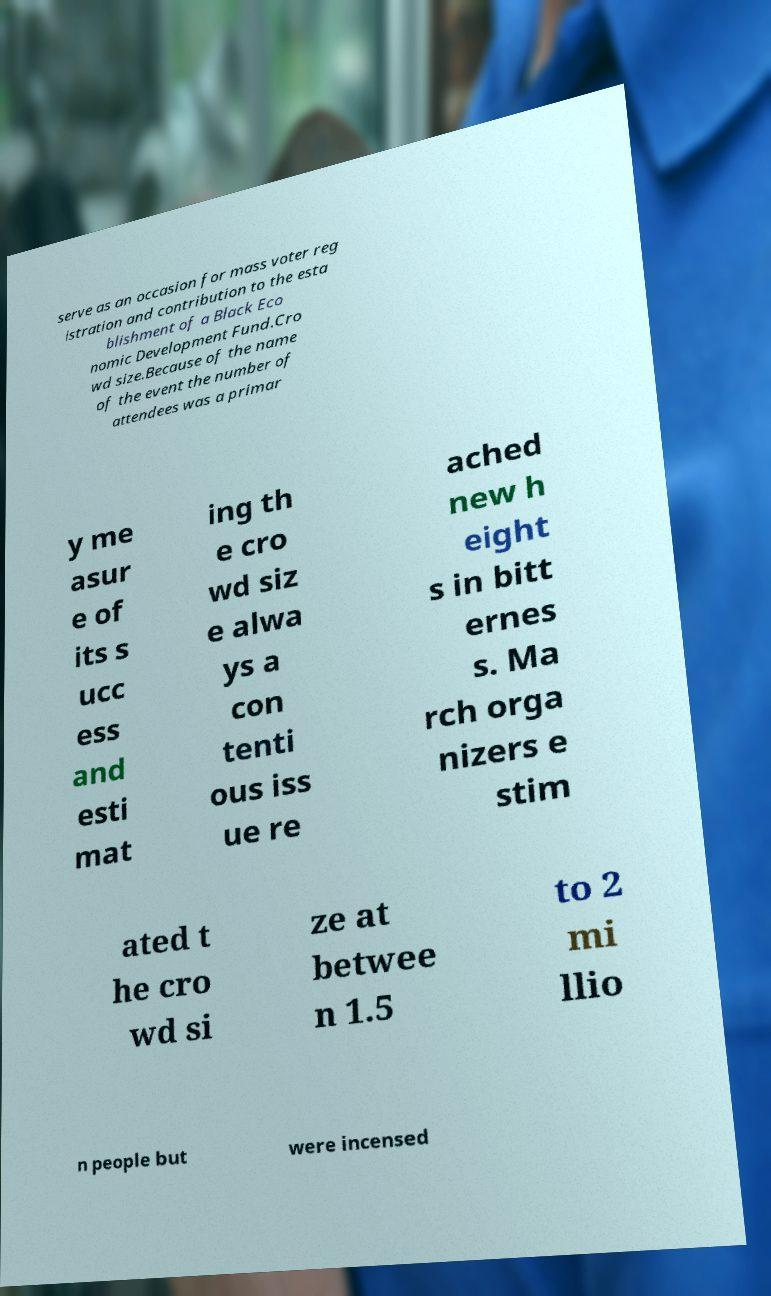Could you assist in decoding the text presented in this image and type it out clearly? serve as an occasion for mass voter reg istration and contribution to the esta blishment of a Black Eco nomic Development Fund.Cro wd size.Because of the name of the event the number of attendees was a primar y me asur e of its s ucc ess and esti mat ing th e cro wd siz e alwa ys a con tenti ous iss ue re ached new h eight s in bitt ernes s. Ma rch orga nizers e stim ated t he cro wd si ze at betwee n 1.5 to 2 mi llio n people but were incensed 